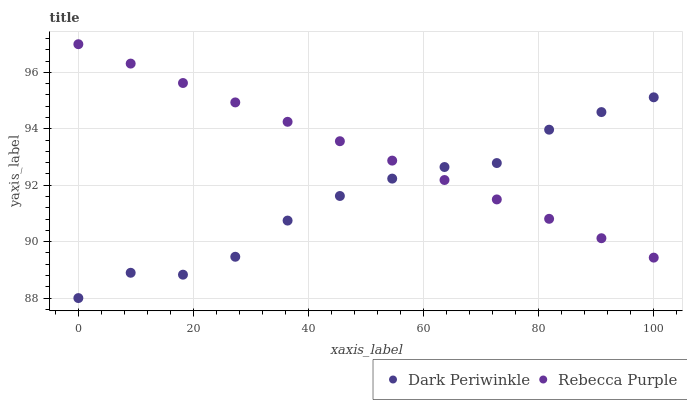Does Dark Periwinkle have the minimum area under the curve?
Answer yes or no. Yes. Does Rebecca Purple have the maximum area under the curve?
Answer yes or no. Yes. Does Rebecca Purple have the minimum area under the curve?
Answer yes or no. No. Is Rebecca Purple the smoothest?
Answer yes or no. Yes. Is Dark Periwinkle the roughest?
Answer yes or no. Yes. Is Rebecca Purple the roughest?
Answer yes or no. No. Does Dark Periwinkle have the lowest value?
Answer yes or no. Yes. Does Rebecca Purple have the lowest value?
Answer yes or no. No. Does Rebecca Purple have the highest value?
Answer yes or no. Yes. Does Rebecca Purple intersect Dark Periwinkle?
Answer yes or no. Yes. Is Rebecca Purple less than Dark Periwinkle?
Answer yes or no. No. Is Rebecca Purple greater than Dark Periwinkle?
Answer yes or no. No. 